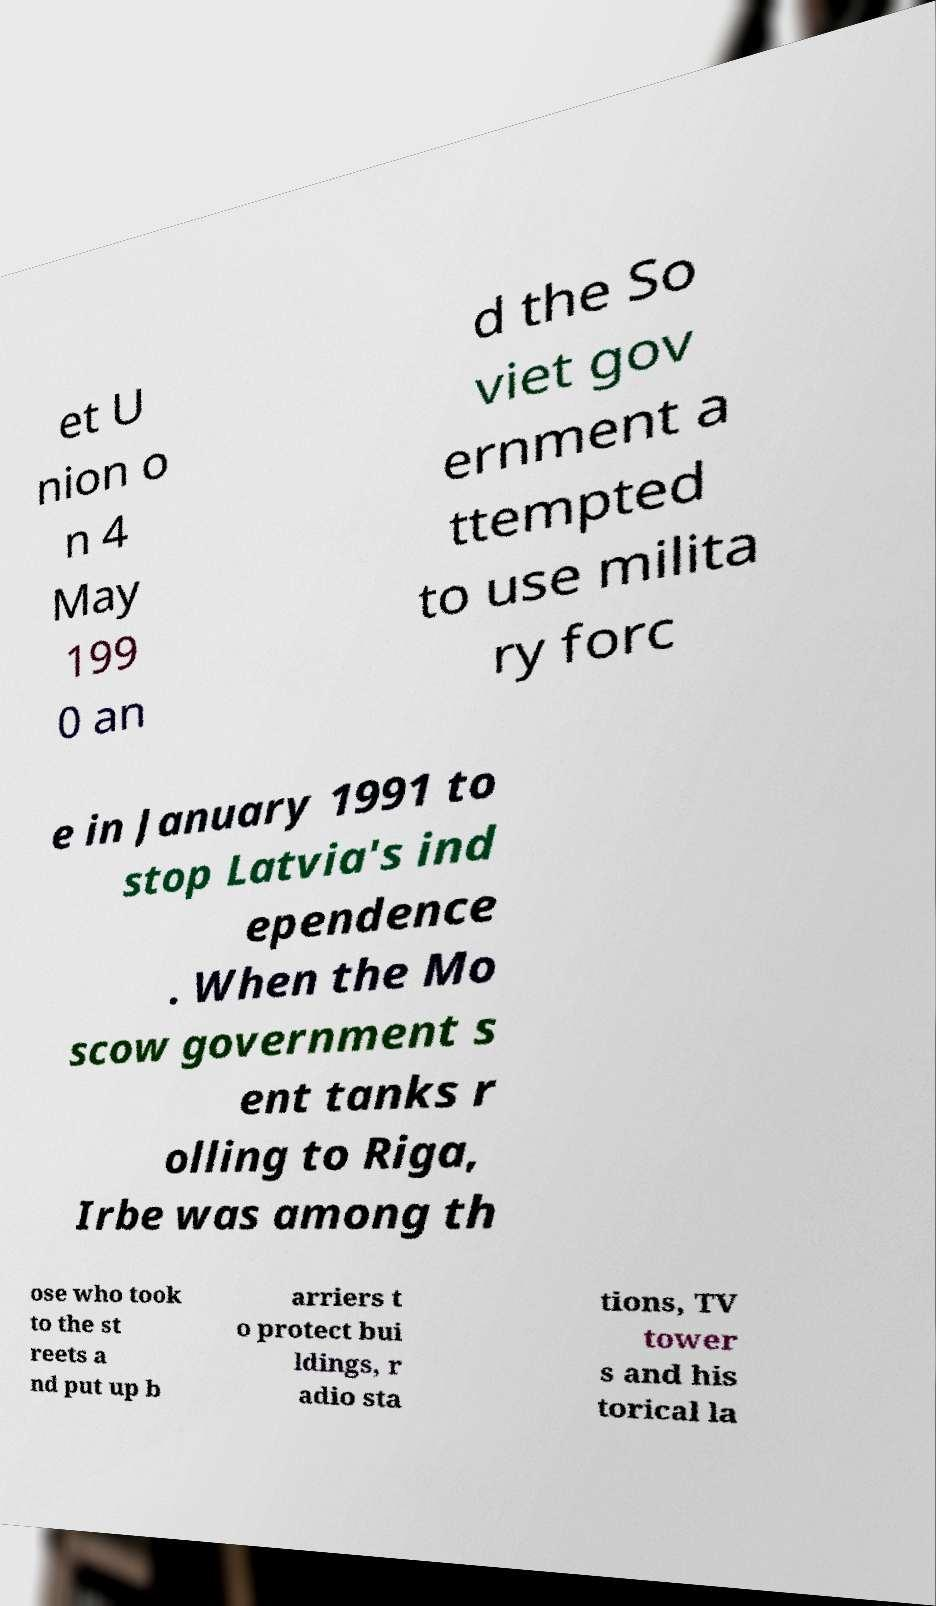Can you read and provide the text displayed in the image?This photo seems to have some interesting text. Can you extract and type it out for me? et U nion o n 4 May 199 0 an d the So viet gov ernment a ttempted to use milita ry forc e in January 1991 to stop Latvia's ind ependence . When the Mo scow government s ent tanks r olling to Riga, Irbe was among th ose who took to the st reets a nd put up b arriers t o protect bui ldings, r adio sta tions, TV tower s and his torical la 